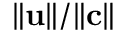Convert formula to latex. <formula><loc_0><loc_0><loc_500><loc_500>\| u \| / \| c \|</formula> 